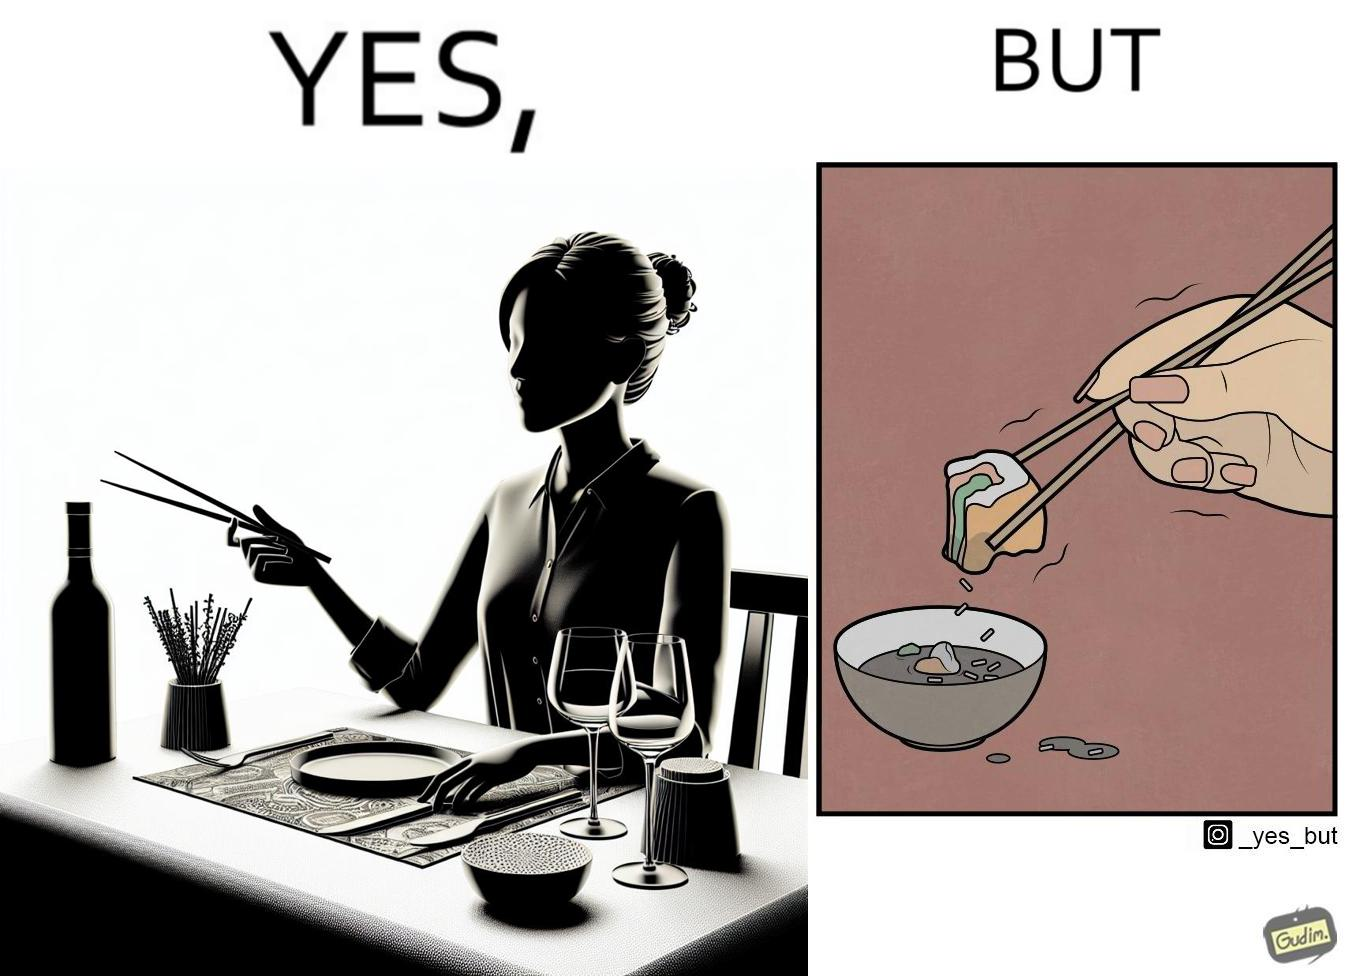What do you see in each half of this image? In the left part of the image: The image shows a woman sitting at a table in a restaruant pointing to chopsticks on her table. There is also a wine glass, a fork and a knief on her table. In the right part of the image: The image shows a person using chopstick to pick up food from the cup. The person is not able to handle food with chopstick well and is dropping the food around the cup on the table. 